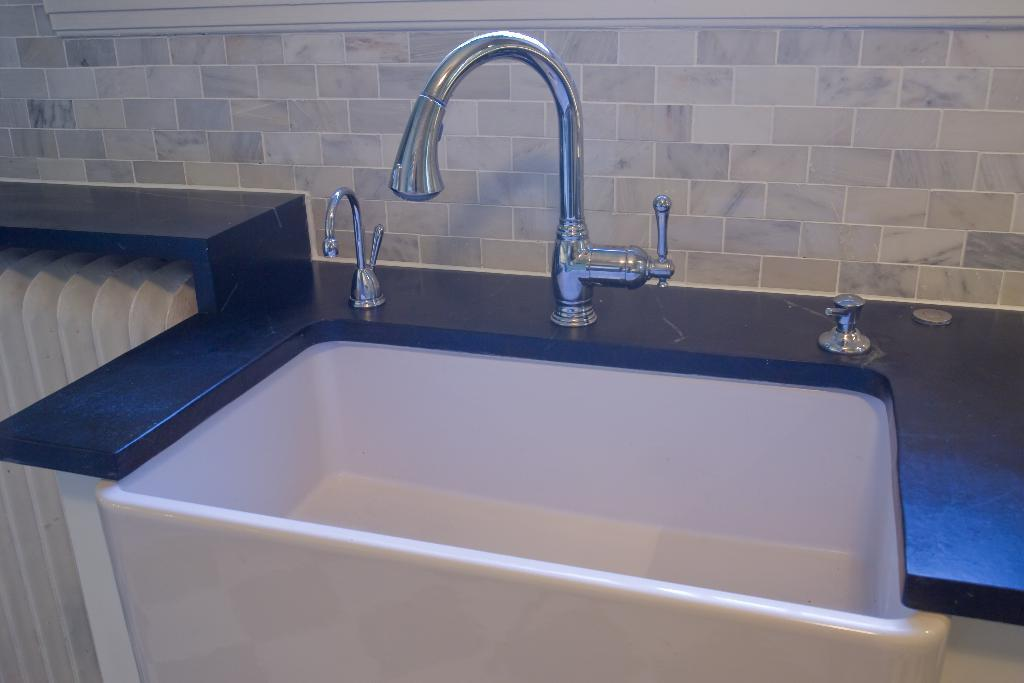What is the main fixture in the image? There is a sink in the image. What is attached to the sink? There is a tap in the image. What is visible behind the sink? There is a wall in the image. How many girls are playing in the grass near the farm in the image? There is no grass, farm, or girls present in the image. The image only features a sink, a tap, and a wall. 